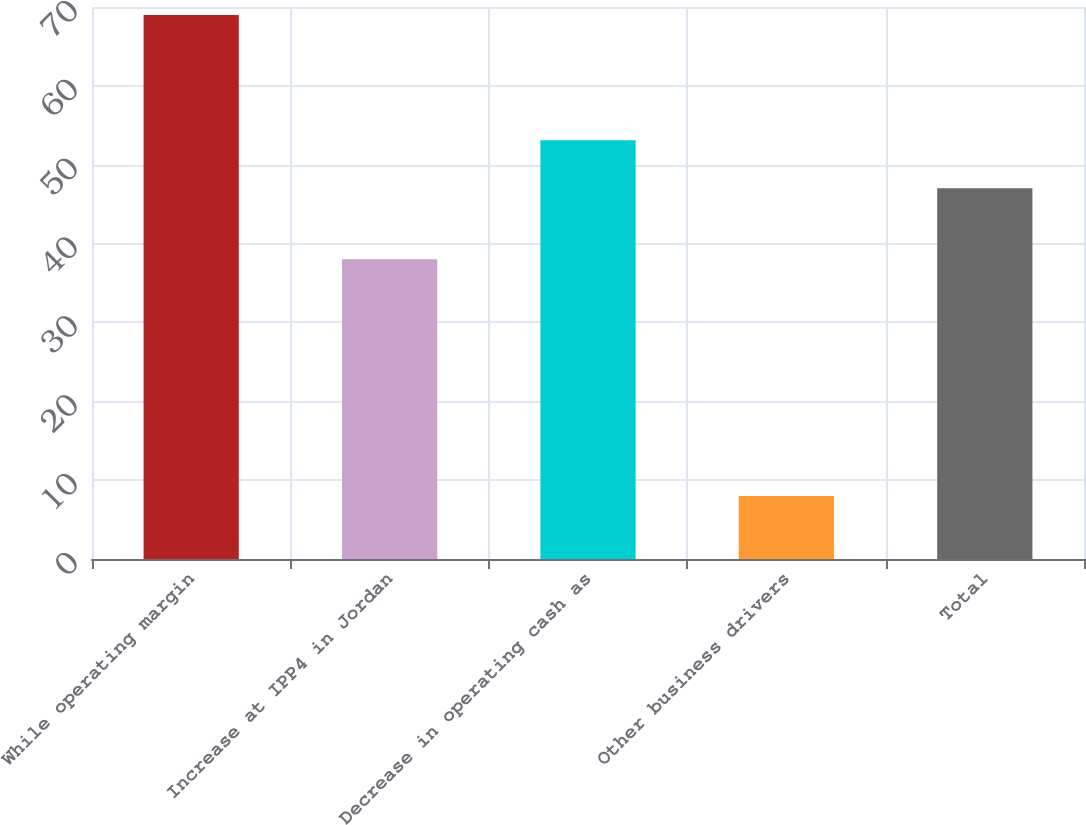<chart> <loc_0><loc_0><loc_500><loc_500><bar_chart><fcel>While operating margin<fcel>Increase at IPP4 in Jordan<fcel>Decrease in operating cash as<fcel>Other business drivers<fcel>Total<nl><fcel>69<fcel>38<fcel>53.1<fcel>8<fcel>47<nl></chart> 